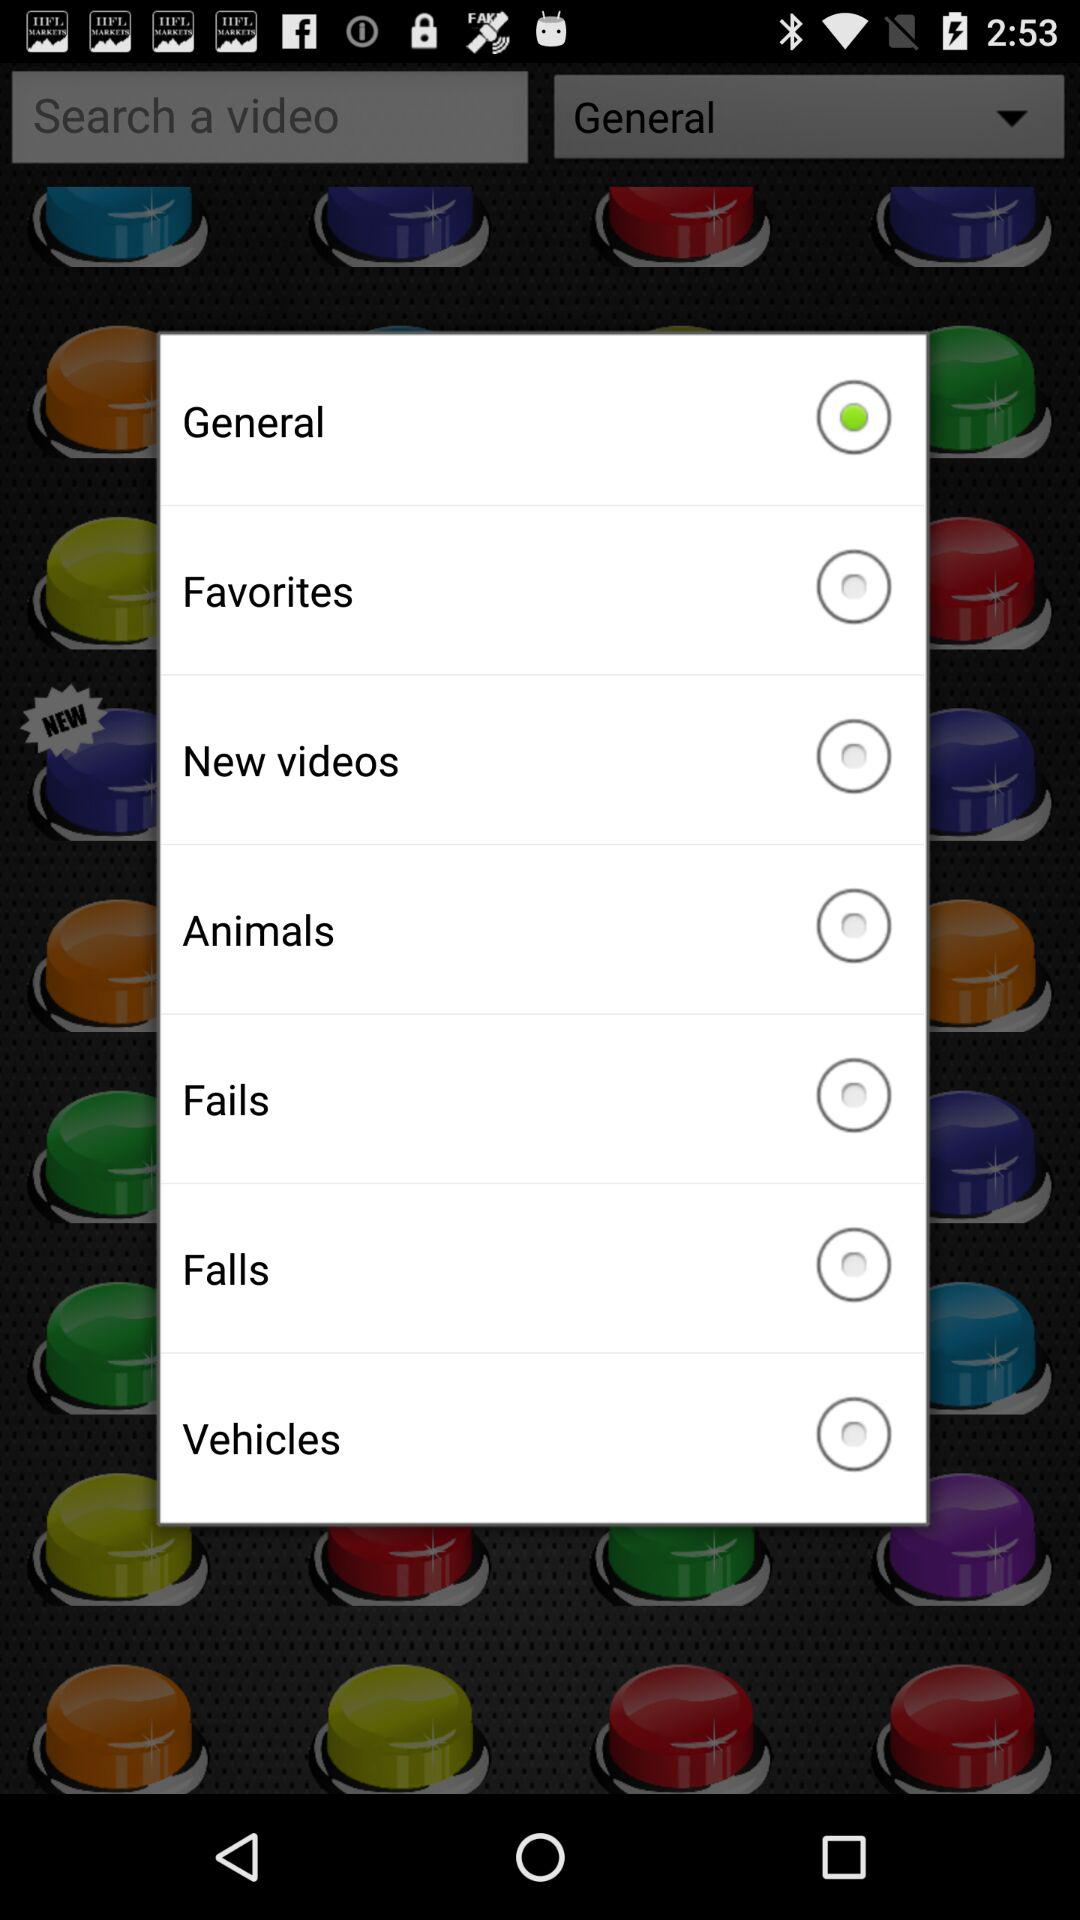Which are the different options? The different options are "General", "Favorites", "New videos", "Animals", "Fails", "Falls" and "Vehicles". 